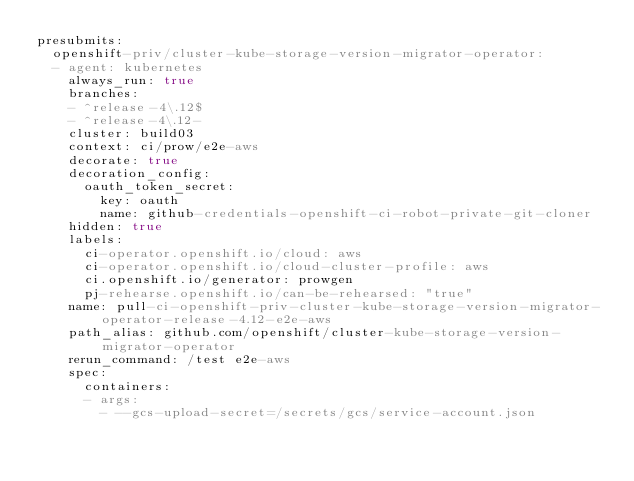<code> <loc_0><loc_0><loc_500><loc_500><_YAML_>presubmits:
  openshift-priv/cluster-kube-storage-version-migrator-operator:
  - agent: kubernetes
    always_run: true
    branches:
    - ^release-4\.12$
    - ^release-4\.12-
    cluster: build03
    context: ci/prow/e2e-aws
    decorate: true
    decoration_config:
      oauth_token_secret:
        key: oauth
        name: github-credentials-openshift-ci-robot-private-git-cloner
    hidden: true
    labels:
      ci-operator.openshift.io/cloud: aws
      ci-operator.openshift.io/cloud-cluster-profile: aws
      ci.openshift.io/generator: prowgen
      pj-rehearse.openshift.io/can-be-rehearsed: "true"
    name: pull-ci-openshift-priv-cluster-kube-storage-version-migrator-operator-release-4.12-e2e-aws
    path_alias: github.com/openshift/cluster-kube-storage-version-migrator-operator
    rerun_command: /test e2e-aws
    spec:
      containers:
      - args:
        - --gcs-upload-secret=/secrets/gcs/service-account.json</code> 